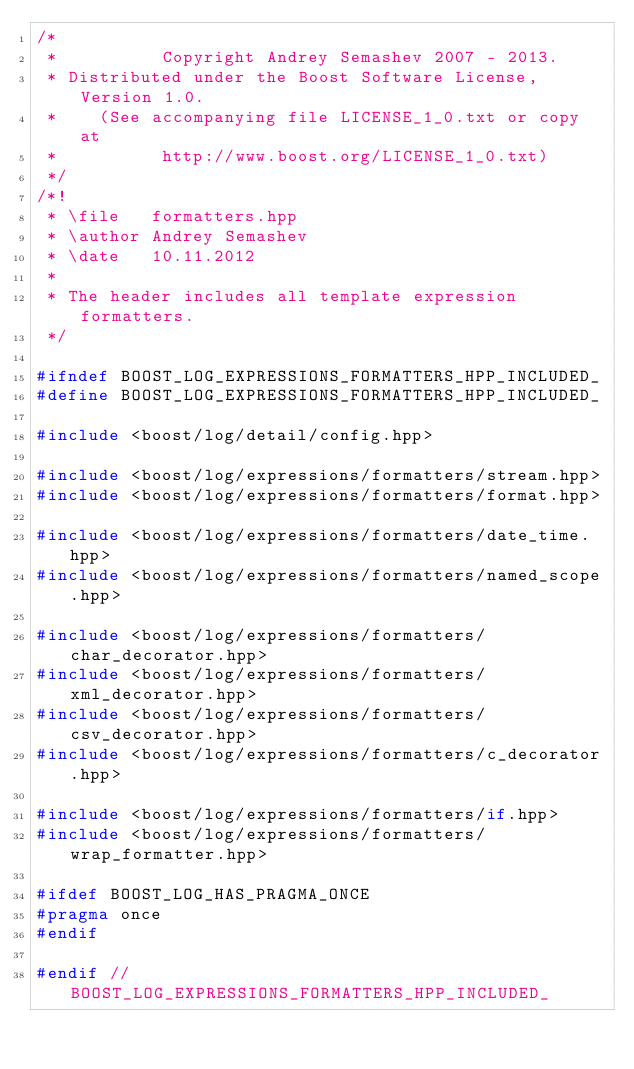Convert code to text. <code><loc_0><loc_0><loc_500><loc_500><_C++_>/*
 *          Copyright Andrey Semashev 2007 - 2013.
 * Distributed under the Boost Software License, Version 1.0.
 *    (See accompanying file LICENSE_1_0.txt or copy at
 *          http://www.boost.org/LICENSE_1_0.txt)
 */
/*!
 * \file   formatters.hpp
 * \author Andrey Semashev
 * \date   10.11.2012
 *
 * The header includes all template expression formatters.
 */

#ifndef BOOST_LOG_EXPRESSIONS_FORMATTERS_HPP_INCLUDED_
#define BOOST_LOG_EXPRESSIONS_FORMATTERS_HPP_INCLUDED_

#include <boost/log/detail/config.hpp>

#include <boost/log/expressions/formatters/stream.hpp>
#include <boost/log/expressions/formatters/format.hpp>

#include <boost/log/expressions/formatters/date_time.hpp>
#include <boost/log/expressions/formatters/named_scope.hpp>

#include <boost/log/expressions/formatters/char_decorator.hpp>
#include <boost/log/expressions/formatters/xml_decorator.hpp>
#include <boost/log/expressions/formatters/csv_decorator.hpp>
#include <boost/log/expressions/formatters/c_decorator.hpp>

#include <boost/log/expressions/formatters/if.hpp>
#include <boost/log/expressions/formatters/wrap_formatter.hpp>

#ifdef BOOST_LOG_HAS_PRAGMA_ONCE
#pragma once
#endif

#endif // BOOST_LOG_EXPRESSIONS_FORMATTERS_HPP_INCLUDED_
</code> 